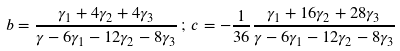<formula> <loc_0><loc_0><loc_500><loc_500>b = \frac { \gamma _ { 1 } + 4 \gamma _ { 2 } + 4 \gamma _ { 3 } } { \gamma - 6 \gamma _ { 1 } - 1 2 \gamma _ { 2 } - 8 \gamma _ { 3 } } \, ; \, c = - \frac { 1 } { 3 6 } \frac { \gamma _ { 1 } + 1 6 \gamma _ { 2 } + 2 8 \gamma _ { 3 } } { \gamma - 6 \gamma _ { 1 } - 1 2 \gamma _ { 2 } - 8 \gamma _ { 3 } }</formula> 